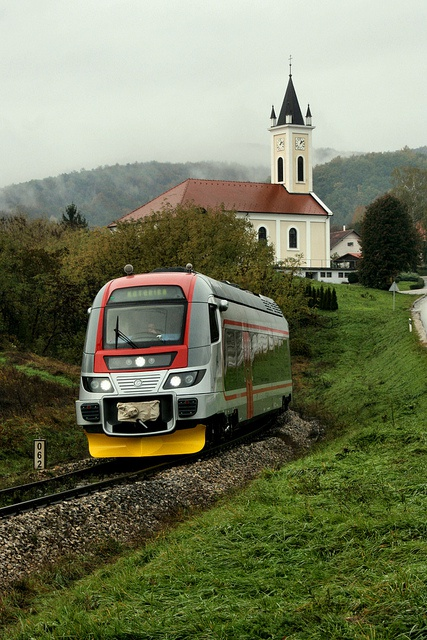Describe the objects in this image and their specific colors. I can see a train in ivory, black, gray, and darkgray tones in this image. 